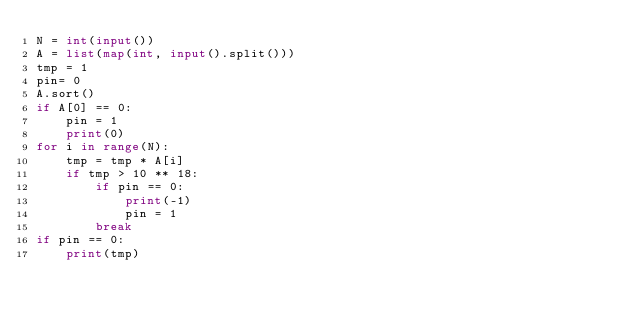<code> <loc_0><loc_0><loc_500><loc_500><_Python_>N = int(input())
A = list(map(int, input().split()))
tmp = 1
pin= 0
A.sort()
if A[0] == 0:
    pin = 1
    print(0)
for i in range(N):
    tmp = tmp * A[i]
    if tmp > 10 ** 18:
        if pin == 0:
            print(-1)
            pin = 1
        break
if pin == 0:
    print(tmp)</code> 